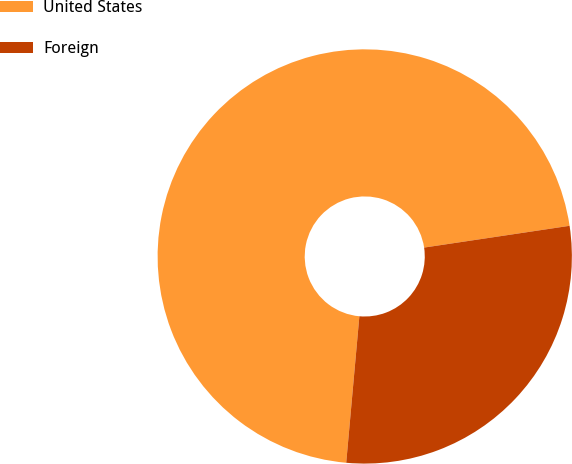Convert chart. <chart><loc_0><loc_0><loc_500><loc_500><pie_chart><fcel>United States<fcel>Foreign<nl><fcel>71.21%<fcel>28.79%<nl></chart> 